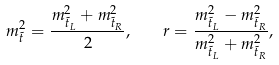Convert formula to latex. <formula><loc_0><loc_0><loc_500><loc_500>m _ { \tilde { t } } ^ { 2 } = \frac { m ^ { 2 } _ { \tilde { t } _ { L } } + m ^ { 2 } _ { \tilde { t } _ { R } } } 2 , \quad r = \frac { m ^ { 2 } _ { \tilde { t } _ { L } } - m ^ { 2 } _ { \tilde { t } _ { R } } } { m ^ { 2 } _ { \tilde { t } _ { L } } + m ^ { 2 } _ { \tilde { t } _ { R } } } ,</formula> 